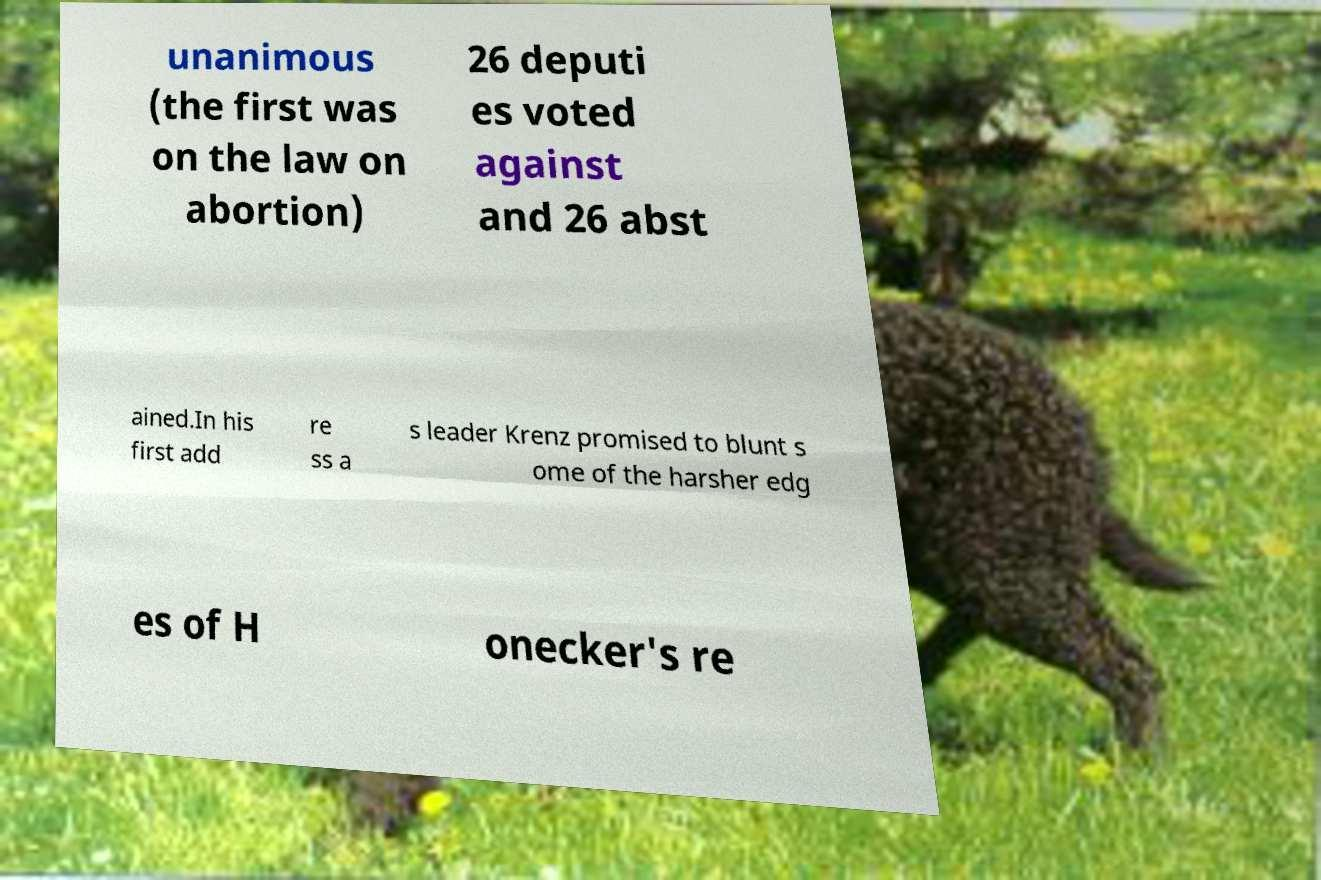Can you accurately transcribe the text from the provided image for me? unanimous (the first was on the law on abortion) 26 deputi es voted against and 26 abst ained.In his first add re ss a s leader Krenz promised to blunt s ome of the harsher edg es of H onecker's re 